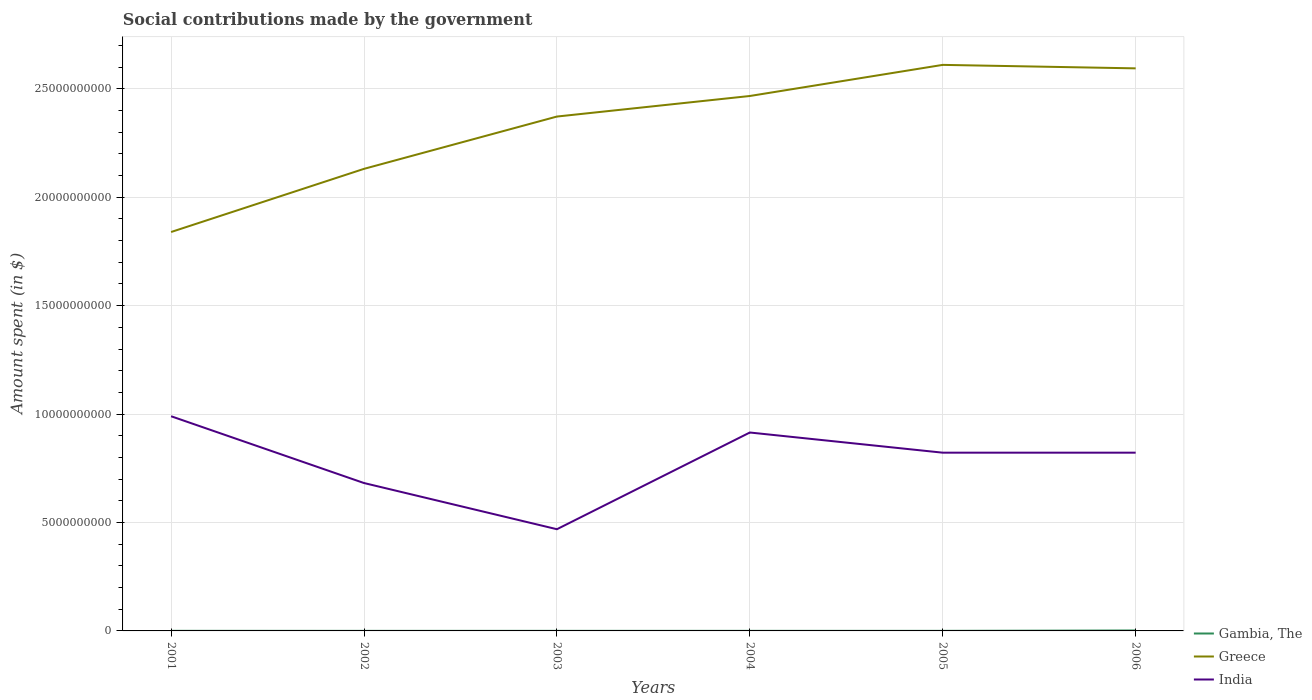How many different coloured lines are there?
Offer a very short reply. 3. Does the line corresponding to Gambia, The intersect with the line corresponding to India?
Give a very brief answer. No. Is the number of lines equal to the number of legend labels?
Make the answer very short. Yes. Across all years, what is the maximum amount spent on social contributions in Gambia, The?
Keep it short and to the point. 2.60e+06. What is the difference between the highest and the second highest amount spent on social contributions in Greece?
Offer a very short reply. 7.71e+09. Is the amount spent on social contributions in India strictly greater than the amount spent on social contributions in Gambia, The over the years?
Offer a very short reply. No. How many years are there in the graph?
Give a very brief answer. 6. Are the values on the major ticks of Y-axis written in scientific E-notation?
Give a very brief answer. No. Does the graph contain grids?
Offer a very short reply. Yes. How many legend labels are there?
Make the answer very short. 3. How are the legend labels stacked?
Your answer should be very brief. Vertical. What is the title of the graph?
Keep it short and to the point. Social contributions made by the government. What is the label or title of the X-axis?
Provide a short and direct response. Years. What is the label or title of the Y-axis?
Provide a succinct answer. Amount spent (in $). What is the Amount spent (in $) in Gambia, The in 2001?
Provide a short and direct response. 4.20e+06. What is the Amount spent (in $) of Greece in 2001?
Offer a very short reply. 1.84e+1. What is the Amount spent (in $) in India in 2001?
Your answer should be very brief. 9.90e+09. What is the Amount spent (in $) of Gambia, The in 2002?
Offer a very short reply. 2.60e+06. What is the Amount spent (in $) in Greece in 2002?
Ensure brevity in your answer.  2.13e+1. What is the Amount spent (in $) of India in 2002?
Your answer should be very brief. 6.82e+09. What is the Amount spent (in $) in Gambia, The in 2003?
Provide a short and direct response. 3.30e+06. What is the Amount spent (in $) in Greece in 2003?
Provide a short and direct response. 2.37e+1. What is the Amount spent (in $) in India in 2003?
Offer a terse response. 4.69e+09. What is the Amount spent (in $) of Gambia, The in 2004?
Your answer should be compact. 3.40e+06. What is the Amount spent (in $) of Greece in 2004?
Offer a terse response. 2.47e+1. What is the Amount spent (in $) of India in 2004?
Make the answer very short. 9.15e+09. What is the Amount spent (in $) of Gambia, The in 2005?
Your response must be concise. 3.70e+06. What is the Amount spent (in $) in Greece in 2005?
Your response must be concise. 2.61e+1. What is the Amount spent (in $) in India in 2005?
Offer a terse response. 8.22e+09. What is the Amount spent (in $) of Gambia, The in 2006?
Offer a terse response. 2.10e+07. What is the Amount spent (in $) in Greece in 2006?
Provide a short and direct response. 2.59e+1. What is the Amount spent (in $) of India in 2006?
Your answer should be compact. 8.22e+09. Across all years, what is the maximum Amount spent (in $) in Gambia, The?
Make the answer very short. 2.10e+07. Across all years, what is the maximum Amount spent (in $) of Greece?
Your answer should be very brief. 2.61e+1. Across all years, what is the maximum Amount spent (in $) in India?
Offer a terse response. 9.90e+09. Across all years, what is the minimum Amount spent (in $) in Gambia, The?
Your response must be concise. 2.60e+06. Across all years, what is the minimum Amount spent (in $) in Greece?
Your answer should be very brief. 1.84e+1. Across all years, what is the minimum Amount spent (in $) in India?
Provide a succinct answer. 4.69e+09. What is the total Amount spent (in $) in Gambia, The in the graph?
Give a very brief answer. 3.82e+07. What is the total Amount spent (in $) in Greece in the graph?
Offer a very short reply. 1.40e+11. What is the total Amount spent (in $) of India in the graph?
Your answer should be very brief. 4.70e+1. What is the difference between the Amount spent (in $) in Gambia, The in 2001 and that in 2002?
Ensure brevity in your answer.  1.60e+06. What is the difference between the Amount spent (in $) in Greece in 2001 and that in 2002?
Your answer should be very brief. -2.91e+09. What is the difference between the Amount spent (in $) of India in 2001 and that in 2002?
Your response must be concise. 3.08e+09. What is the difference between the Amount spent (in $) in Greece in 2001 and that in 2003?
Ensure brevity in your answer.  -5.32e+09. What is the difference between the Amount spent (in $) in India in 2001 and that in 2003?
Keep it short and to the point. 5.21e+09. What is the difference between the Amount spent (in $) in Greece in 2001 and that in 2004?
Give a very brief answer. -6.27e+09. What is the difference between the Amount spent (in $) of India in 2001 and that in 2004?
Your response must be concise. 7.50e+08. What is the difference between the Amount spent (in $) of Gambia, The in 2001 and that in 2005?
Offer a very short reply. 5.00e+05. What is the difference between the Amount spent (in $) of Greece in 2001 and that in 2005?
Offer a very short reply. -7.71e+09. What is the difference between the Amount spent (in $) in India in 2001 and that in 2005?
Make the answer very short. 1.68e+09. What is the difference between the Amount spent (in $) of Gambia, The in 2001 and that in 2006?
Keep it short and to the point. -1.68e+07. What is the difference between the Amount spent (in $) in Greece in 2001 and that in 2006?
Give a very brief answer. -7.55e+09. What is the difference between the Amount spent (in $) of India in 2001 and that in 2006?
Offer a terse response. 1.68e+09. What is the difference between the Amount spent (in $) of Gambia, The in 2002 and that in 2003?
Make the answer very short. -7.00e+05. What is the difference between the Amount spent (in $) in Greece in 2002 and that in 2003?
Your answer should be very brief. -2.41e+09. What is the difference between the Amount spent (in $) of India in 2002 and that in 2003?
Provide a short and direct response. 2.13e+09. What is the difference between the Amount spent (in $) in Gambia, The in 2002 and that in 2004?
Make the answer very short. -8.00e+05. What is the difference between the Amount spent (in $) in Greece in 2002 and that in 2004?
Keep it short and to the point. -3.36e+09. What is the difference between the Amount spent (in $) in India in 2002 and that in 2004?
Ensure brevity in your answer.  -2.33e+09. What is the difference between the Amount spent (in $) in Gambia, The in 2002 and that in 2005?
Keep it short and to the point. -1.10e+06. What is the difference between the Amount spent (in $) in Greece in 2002 and that in 2005?
Provide a succinct answer. -4.80e+09. What is the difference between the Amount spent (in $) of India in 2002 and that in 2005?
Offer a terse response. -1.40e+09. What is the difference between the Amount spent (in $) in Gambia, The in 2002 and that in 2006?
Keep it short and to the point. -1.84e+07. What is the difference between the Amount spent (in $) of Greece in 2002 and that in 2006?
Offer a terse response. -4.63e+09. What is the difference between the Amount spent (in $) of India in 2002 and that in 2006?
Your answer should be compact. -1.40e+09. What is the difference between the Amount spent (in $) in Gambia, The in 2003 and that in 2004?
Your answer should be compact. -1.00e+05. What is the difference between the Amount spent (in $) of Greece in 2003 and that in 2004?
Your answer should be very brief. -9.48e+08. What is the difference between the Amount spent (in $) of India in 2003 and that in 2004?
Offer a very short reply. -4.46e+09. What is the difference between the Amount spent (in $) in Gambia, The in 2003 and that in 2005?
Keep it short and to the point. -4.00e+05. What is the difference between the Amount spent (in $) of Greece in 2003 and that in 2005?
Provide a succinct answer. -2.38e+09. What is the difference between the Amount spent (in $) in India in 2003 and that in 2005?
Keep it short and to the point. -3.53e+09. What is the difference between the Amount spent (in $) in Gambia, The in 2003 and that in 2006?
Ensure brevity in your answer.  -1.77e+07. What is the difference between the Amount spent (in $) of Greece in 2003 and that in 2006?
Your answer should be very brief. -2.22e+09. What is the difference between the Amount spent (in $) in India in 2003 and that in 2006?
Offer a very short reply. -3.53e+09. What is the difference between the Amount spent (in $) of Greece in 2004 and that in 2005?
Offer a very short reply. -1.44e+09. What is the difference between the Amount spent (in $) in India in 2004 and that in 2005?
Offer a terse response. 9.30e+08. What is the difference between the Amount spent (in $) in Gambia, The in 2004 and that in 2006?
Provide a succinct answer. -1.76e+07. What is the difference between the Amount spent (in $) in Greece in 2004 and that in 2006?
Keep it short and to the point. -1.27e+09. What is the difference between the Amount spent (in $) of India in 2004 and that in 2006?
Your response must be concise. 9.30e+08. What is the difference between the Amount spent (in $) in Gambia, The in 2005 and that in 2006?
Provide a short and direct response. -1.73e+07. What is the difference between the Amount spent (in $) in Greece in 2005 and that in 2006?
Provide a succinct answer. 1.61e+08. What is the difference between the Amount spent (in $) in Gambia, The in 2001 and the Amount spent (in $) in Greece in 2002?
Keep it short and to the point. -2.13e+1. What is the difference between the Amount spent (in $) in Gambia, The in 2001 and the Amount spent (in $) in India in 2002?
Provide a short and direct response. -6.82e+09. What is the difference between the Amount spent (in $) in Greece in 2001 and the Amount spent (in $) in India in 2002?
Provide a succinct answer. 1.16e+1. What is the difference between the Amount spent (in $) of Gambia, The in 2001 and the Amount spent (in $) of Greece in 2003?
Give a very brief answer. -2.37e+1. What is the difference between the Amount spent (in $) in Gambia, The in 2001 and the Amount spent (in $) in India in 2003?
Provide a short and direct response. -4.69e+09. What is the difference between the Amount spent (in $) in Greece in 2001 and the Amount spent (in $) in India in 2003?
Give a very brief answer. 1.37e+1. What is the difference between the Amount spent (in $) in Gambia, The in 2001 and the Amount spent (in $) in Greece in 2004?
Keep it short and to the point. -2.47e+1. What is the difference between the Amount spent (in $) in Gambia, The in 2001 and the Amount spent (in $) in India in 2004?
Provide a short and direct response. -9.15e+09. What is the difference between the Amount spent (in $) in Greece in 2001 and the Amount spent (in $) in India in 2004?
Your answer should be compact. 9.25e+09. What is the difference between the Amount spent (in $) in Gambia, The in 2001 and the Amount spent (in $) in Greece in 2005?
Your response must be concise. -2.61e+1. What is the difference between the Amount spent (in $) in Gambia, The in 2001 and the Amount spent (in $) in India in 2005?
Offer a terse response. -8.22e+09. What is the difference between the Amount spent (in $) in Greece in 2001 and the Amount spent (in $) in India in 2005?
Your response must be concise. 1.02e+1. What is the difference between the Amount spent (in $) in Gambia, The in 2001 and the Amount spent (in $) in Greece in 2006?
Ensure brevity in your answer.  -2.59e+1. What is the difference between the Amount spent (in $) in Gambia, The in 2001 and the Amount spent (in $) in India in 2006?
Your response must be concise. -8.22e+09. What is the difference between the Amount spent (in $) of Greece in 2001 and the Amount spent (in $) of India in 2006?
Your answer should be very brief. 1.02e+1. What is the difference between the Amount spent (in $) in Gambia, The in 2002 and the Amount spent (in $) in Greece in 2003?
Give a very brief answer. -2.37e+1. What is the difference between the Amount spent (in $) of Gambia, The in 2002 and the Amount spent (in $) of India in 2003?
Your response must be concise. -4.69e+09. What is the difference between the Amount spent (in $) of Greece in 2002 and the Amount spent (in $) of India in 2003?
Ensure brevity in your answer.  1.66e+1. What is the difference between the Amount spent (in $) in Gambia, The in 2002 and the Amount spent (in $) in Greece in 2004?
Offer a terse response. -2.47e+1. What is the difference between the Amount spent (in $) in Gambia, The in 2002 and the Amount spent (in $) in India in 2004?
Keep it short and to the point. -9.15e+09. What is the difference between the Amount spent (in $) of Greece in 2002 and the Amount spent (in $) of India in 2004?
Your response must be concise. 1.22e+1. What is the difference between the Amount spent (in $) of Gambia, The in 2002 and the Amount spent (in $) of Greece in 2005?
Your answer should be very brief. -2.61e+1. What is the difference between the Amount spent (in $) in Gambia, The in 2002 and the Amount spent (in $) in India in 2005?
Offer a terse response. -8.22e+09. What is the difference between the Amount spent (in $) in Greece in 2002 and the Amount spent (in $) in India in 2005?
Your answer should be very brief. 1.31e+1. What is the difference between the Amount spent (in $) of Gambia, The in 2002 and the Amount spent (in $) of Greece in 2006?
Make the answer very short. -2.59e+1. What is the difference between the Amount spent (in $) of Gambia, The in 2002 and the Amount spent (in $) of India in 2006?
Offer a terse response. -8.22e+09. What is the difference between the Amount spent (in $) in Greece in 2002 and the Amount spent (in $) in India in 2006?
Your answer should be very brief. 1.31e+1. What is the difference between the Amount spent (in $) of Gambia, The in 2003 and the Amount spent (in $) of Greece in 2004?
Make the answer very short. -2.47e+1. What is the difference between the Amount spent (in $) in Gambia, The in 2003 and the Amount spent (in $) in India in 2004?
Give a very brief answer. -9.15e+09. What is the difference between the Amount spent (in $) in Greece in 2003 and the Amount spent (in $) in India in 2004?
Provide a succinct answer. 1.46e+1. What is the difference between the Amount spent (in $) of Gambia, The in 2003 and the Amount spent (in $) of Greece in 2005?
Keep it short and to the point. -2.61e+1. What is the difference between the Amount spent (in $) in Gambia, The in 2003 and the Amount spent (in $) in India in 2005?
Your answer should be compact. -8.22e+09. What is the difference between the Amount spent (in $) in Greece in 2003 and the Amount spent (in $) in India in 2005?
Ensure brevity in your answer.  1.55e+1. What is the difference between the Amount spent (in $) in Gambia, The in 2003 and the Amount spent (in $) in Greece in 2006?
Your response must be concise. -2.59e+1. What is the difference between the Amount spent (in $) in Gambia, The in 2003 and the Amount spent (in $) in India in 2006?
Provide a short and direct response. -8.22e+09. What is the difference between the Amount spent (in $) in Greece in 2003 and the Amount spent (in $) in India in 2006?
Offer a terse response. 1.55e+1. What is the difference between the Amount spent (in $) in Gambia, The in 2004 and the Amount spent (in $) in Greece in 2005?
Offer a terse response. -2.61e+1. What is the difference between the Amount spent (in $) in Gambia, The in 2004 and the Amount spent (in $) in India in 2005?
Offer a terse response. -8.22e+09. What is the difference between the Amount spent (in $) in Greece in 2004 and the Amount spent (in $) in India in 2005?
Ensure brevity in your answer.  1.64e+1. What is the difference between the Amount spent (in $) in Gambia, The in 2004 and the Amount spent (in $) in Greece in 2006?
Your response must be concise. -2.59e+1. What is the difference between the Amount spent (in $) of Gambia, The in 2004 and the Amount spent (in $) of India in 2006?
Your response must be concise. -8.22e+09. What is the difference between the Amount spent (in $) of Greece in 2004 and the Amount spent (in $) of India in 2006?
Provide a succinct answer. 1.64e+1. What is the difference between the Amount spent (in $) of Gambia, The in 2005 and the Amount spent (in $) of Greece in 2006?
Your answer should be compact. -2.59e+1. What is the difference between the Amount spent (in $) of Gambia, The in 2005 and the Amount spent (in $) of India in 2006?
Keep it short and to the point. -8.22e+09. What is the difference between the Amount spent (in $) of Greece in 2005 and the Amount spent (in $) of India in 2006?
Your answer should be compact. 1.79e+1. What is the average Amount spent (in $) of Gambia, The per year?
Offer a very short reply. 6.37e+06. What is the average Amount spent (in $) of Greece per year?
Give a very brief answer. 2.34e+1. What is the average Amount spent (in $) in India per year?
Ensure brevity in your answer.  7.83e+09. In the year 2001, what is the difference between the Amount spent (in $) in Gambia, The and Amount spent (in $) in Greece?
Give a very brief answer. -1.84e+1. In the year 2001, what is the difference between the Amount spent (in $) in Gambia, The and Amount spent (in $) in India?
Provide a short and direct response. -9.90e+09. In the year 2001, what is the difference between the Amount spent (in $) in Greece and Amount spent (in $) in India?
Provide a short and direct response. 8.50e+09. In the year 2002, what is the difference between the Amount spent (in $) of Gambia, The and Amount spent (in $) of Greece?
Give a very brief answer. -2.13e+1. In the year 2002, what is the difference between the Amount spent (in $) of Gambia, The and Amount spent (in $) of India?
Give a very brief answer. -6.82e+09. In the year 2002, what is the difference between the Amount spent (in $) in Greece and Amount spent (in $) in India?
Provide a succinct answer. 1.45e+1. In the year 2003, what is the difference between the Amount spent (in $) in Gambia, The and Amount spent (in $) in Greece?
Your answer should be very brief. -2.37e+1. In the year 2003, what is the difference between the Amount spent (in $) of Gambia, The and Amount spent (in $) of India?
Your answer should be compact. -4.69e+09. In the year 2003, what is the difference between the Amount spent (in $) of Greece and Amount spent (in $) of India?
Make the answer very short. 1.90e+1. In the year 2004, what is the difference between the Amount spent (in $) in Gambia, The and Amount spent (in $) in Greece?
Keep it short and to the point. -2.47e+1. In the year 2004, what is the difference between the Amount spent (in $) of Gambia, The and Amount spent (in $) of India?
Make the answer very short. -9.15e+09. In the year 2004, what is the difference between the Amount spent (in $) in Greece and Amount spent (in $) in India?
Offer a very short reply. 1.55e+1. In the year 2005, what is the difference between the Amount spent (in $) of Gambia, The and Amount spent (in $) of Greece?
Your answer should be compact. -2.61e+1. In the year 2005, what is the difference between the Amount spent (in $) in Gambia, The and Amount spent (in $) in India?
Make the answer very short. -8.22e+09. In the year 2005, what is the difference between the Amount spent (in $) in Greece and Amount spent (in $) in India?
Offer a very short reply. 1.79e+1. In the year 2006, what is the difference between the Amount spent (in $) in Gambia, The and Amount spent (in $) in Greece?
Offer a terse response. -2.59e+1. In the year 2006, what is the difference between the Amount spent (in $) in Gambia, The and Amount spent (in $) in India?
Make the answer very short. -8.20e+09. In the year 2006, what is the difference between the Amount spent (in $) in Greece and Amount spent (in $) in India?
Make the answer very short. 1.77e+1. What is the ratio of the Amount spent (in $) of Gambia, The in 2001 to that in 2002?
Make the answer very short. 1.62. What is the ratio of the Amount spent (in $) in Greece in 2001 to that in 2002?
Make the answer very short. 0.86. What is the ratio of the Amount spent (in $) in India in 2001 to that in 2002?
Offer a terse response. 1.45. What is the ratio of the Amount spent (in $) of Gambia, The in 2001 to that in 2003?
Provide a short and direct response. 1.27. What is the ratio of the Amount spent (in $) in Greece in 2001 to that in 2003?
Make the answer very short. 0.78. What is the ratio of the Amount spent (in $) in India in 2001 to that in 2003?
Your answer should be compact. 2.11. What is the ratio of the Amount spent (in $) in Gambia, The in 2001 to that in 2004?
Your answer should be very brief. 1.24. What is the ratio of the Amount spent (in $) in Greece in 2001 to that in 2004?
Offer a terse response. 0.75. What is the ratio of the Amount spent (in $) of India in 2001 to that in 2004?
Your answer should be very brief. 1.08. What is the ratio of the Amount spent (in $) of Gambia, The in 2001 to that in 2005?
Your response must be concise. 1.14. What is the ratio of the Amount spent (in $) in Greece in 2001 to that in 2005?
Provide a short and direct response. 0.7. What is the ratio of the Amount spent (in $) of India in 2001 to that in 2005?
Ensure brevity in your answer.  1.2. What is the ratio of the Amount spent (in $) in Greece in 2001 to that in 2006?
Keep it short and to the point. 0.71. What is the ratio of the Amount spent (in $) in India in 2001 to that in 2006?
Your answer should be very brief. 1.2. What is the ratio of the Amount spent (in $) in Gambia, The in 2002 to that in 2003?
Give a very brief answer. 0.79. What is the ratio of the Amount spent (in $) of Greece in 2002 to that in 2003?
Your answer should be very brief. 0.9. What is the ratio of the Amount spent (in $) of India in 2002 to that in 2003?
Your answer should be very brief. 1.45. What is the ratio of the Amount spent (in $) of Gambia, The in 2002 to that in 2004?
Your answer should be compact. 0.76. What is the ratio of the Amount spent (in $) in Greece in 2002 to that in 2004?
Ensure brevity in your answer.  0.86. What is the ratio of the Amount spent (in $) in India in 2002 to that in 2004?
Your answer should be very brief. 0.75. What is the ratio of the Amount spent (in $) of Gambia, The in 2002 to that in 2005?
Keep it short and to the point. 0.7. What is the ratio of the Amount spent (in $) of Greece in 2002 to that in 2005?
Offer a terse response. 0.82. What is the ratio of the Amount spent (in $) of India in 2002 to that in 2005?
Your answer should be compact. 0.83. What is the ratio of the Amount spent (in $) in Gambia, The in 2002 to that in 2006?
Offer a very short reply. 0.12. What is the ratio of the Amount spent (in $) of Greece in 2002 to that in 2006?
Your answer should be very brief. 0.82. What is the ratio of the Amount spent (in $) of India in 2002 to that in 2006?
Your answer should be very brief. 0.83. What is the ratio of the Amount spent (in $) of Gambia, The in 2003 to that in 2004?
Provide a succinct answer. 0.97. What is the ratio of the Amount spent (in $) of Greece in 2003 to that in 2004?
Make the answer very short. 0.96. What is the ratio of the Amount spent (in $) in India in 2003 to that in 2004?
Offer a very short reply. 0.51. What is the ratio of the Amount spent (in $) of Gambia, The in 2003 to that in 2005?
Make the answer very short. 0.89. What is the ratio of the Amount spent (in $) in Greece in 2003 to that in 2005?
Make the answer very short. 0.91. What is the ratio of the Amount spent (in $) of India in 2003 to that in 2005?
Offer a terse response. 0.57. What is the ratio of the Amount spent (in $) in Gambia, The in 2003 to that in 2006?
Keep it short and to the point. 0.16. What is the ratio of the Amount spent (in $) of Greece in 2003 to that in 2006?
Your answer should be compact. 0.91. What is the ratio of the Amount spent (in $) in India in 2003 to that in 2006?
Ensure brevity in your answer.  0.57. What is the ratio of the Amount spent (in $) of Gambia, The in 2004 to that in 2005?
Keep it short and to the point. 0.92. What is the ratio of the Amount spent (in $) in Greece in 2004 to that in 2005?
Your response must be concise. 0.94. What is the ratio of the Amount spent (in $) in India in 2004 to that in 2005?
Make the answer very short. 1.11. What is the ratio of the Amount spent (in $) of Gambia, The in 2004 to that in 2006?
Provide a succinct answer. 0.16. What is the ratio of the Amount spent (in $) of Greece in 2004 to that in 2006?
Keep it short and to the point. 0.95. What is the ratio of the Amount spent (in $) in India in 2004 to that in 2006?
Your response must be concise. 1.11. What is the ratio of the Amount spent (in $) in Gambia, The in 2005 to that in 2006?
Keep it short and to the point. 0.18. What is the ratio of the Amount spent (in $) in India in 2005 to that in 2006?
Make the answer very short. 1. What is the difference between the highest and the second highest Amount spent (in $) in Gambia, The?
Keep it short and to the point. 1.68e+07. What is the difference between the highest and the second highest Amount spent (in $) in Greece?
Ensure brevity in your answer.  1.61e+08. What is the difference between the highest and the second highest Amount spent (in $) in India?
Make the answer very short. 7.50e+08. What is the difference between the highest and the lowest Amount spent (in $) in Gambia, The?
Your answer should be very brief. 1.84e+07. What is the difference between the highest and the lowest Amount spent (in $) in Greece?
Keep it short and to the point. 7.71e+09. What is the difference between the highest and the lowest Amount spent (in $) in India?
Your answer should be compact. 5.21e+09. 